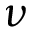Convert formula to latex. <formula><loc_0><loc_0><loc_500><loc_500>\nu</formula> 